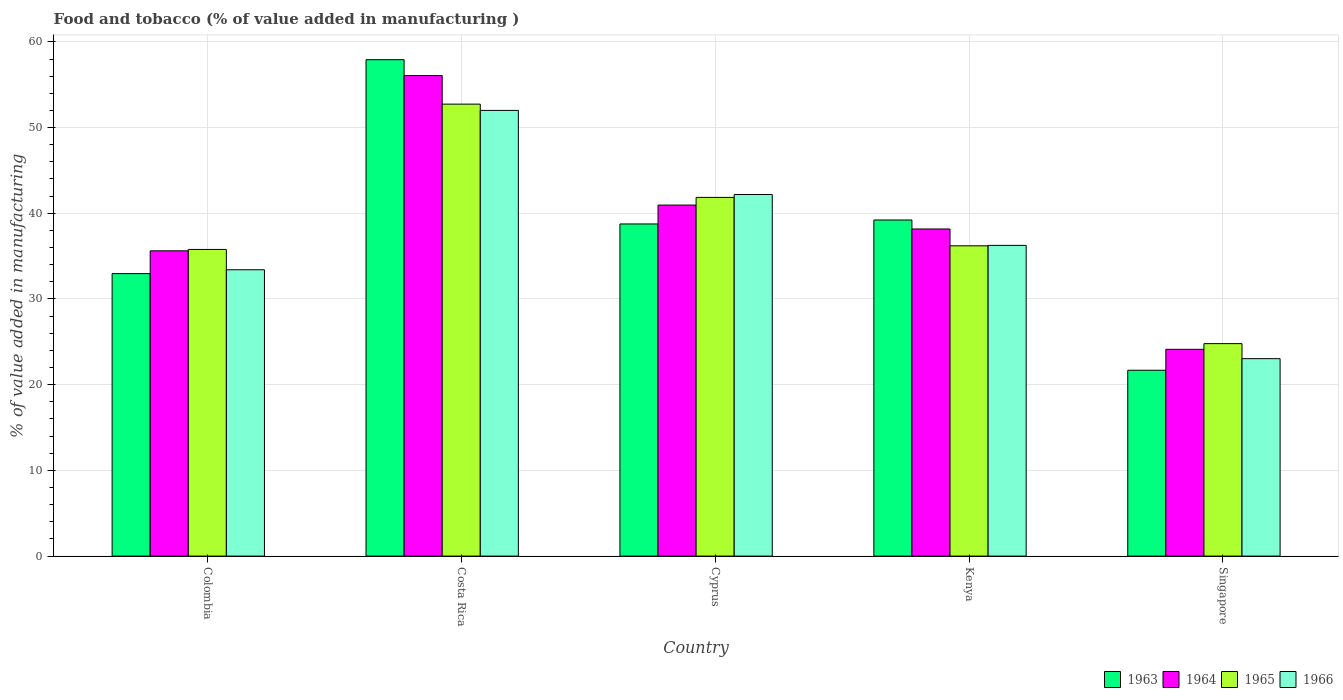How many different coloured bars are there?
Offer a terse response. 4. Are the number of bars per tick equal to the number of legend labels?
Your answer should be compact. Yes. Are the number of bars on each tick of the X-axis equal?
Keep it short and to the point. Yes. How many bars are there on the 2nd tick from the left?
Your answer should be very brief. 4. How many bars are there on the 2nd tick from the right?
Provide a succinct answer. 4. What is the label of the 1st group of bars from the left?
Make the answer very short. Colombia. In how many cases, is the number of bars for a given country not equal to the number of legend labels?
Ensure brevity in your answer.  0. What is the value added in manufacturing food and tobacco in 1963 in Cyprus?
Keep it short and to the point. 38.75. Across all countries, what is the maximum value added in manufacturing food and tobacco in 1963?
Your answer should be very brief. 57.92. Across all countries, what is the minimum value added in manufacturing food and tobacco in 1965?
Provide a succinct answer. 24.79. In which country was the value added in manufacturing food and tobacco in 1965 minimum?
Provide a short and direct response. Singapore. What is the total value added in manufacturing food and tobacco in 1963 in the graph?
Make the answer very short. 190.54. What is the difference between the value added in manufacturing food and tobacco in 1965 in Colombia and that in Singapore?
Keep it short and to the point. 10.99. What is the difference between the value added in manufacturing food and tobacco in 1964 in Colombia and the value added in manufacturing food and tobacco in 1963 in Singapore?
Offer a terse response. 13.93. What is the average value added in manufacturing food and tobacco in 1963 per country?
Provide a succinct answer. 38.11. What is the difference between the value added in manufacturing food and tobacco of/in 1963 and value added in manufacturing food and tobacco of/in 1965 in Cyprus?
Your response must be concise. -3.1. In how many countries, is the value added in manufacturing food and tobacco in 1963 greater than 54 %?
Ensure brevity in your answer.  1. What is the ratio of the value added in manufacturing food and tobacco in 1964 in Costa Rica to that in Kenya?
Your answer should be compact. 1.47. Is the difference between the value added in manufacturing food and tobacco in 1963 in Cyprus and Singapore greater than the difference between the value added in manufacturing food and tobacco in 1965 in Cyprus and Singapore?
Ensure brevity in your answer.  Yes. What is the difference between the highest and the second highest value added in manufacturing food and tobacco in 1964?
Offer a terse response. 15.11. What is the difference between the highest and the lowest value added in manufacturing food and tobacco in 1965?
Ensure brevity in your answer.  27.94. Is it the case that in every country, the sum of the value added in manufacturing food and tobacco in 1965 and value added in manufacturing food and tobacco in 1964 is greater than the sum of value added in manufacturing food and tobacco in 1966 and value added in manufacturing food and tobacco in 1963?
Give a very brief answer. No. What does the 4th bar from the left in Cyprus represents?
Your response must be concise. 1966. What does the 1st bar from the right in Singapore represents?
Offer a very short reply. 1966. Is it the case that in every country, the sum of the value added in manufacturing food and tobacco in 1963 and value added in manufacturing food and tobacco in 1966 is greater than the value added in manufacturing food and tobacco in 1964?
Offer a terse response. Yes. How many bars are there?
Offer a terse response. 20. How many countries are there in the graph?
Your answer should be very brief. 5. What is the difference between two consecutive major ticks on the Y-axis?
Offer a terse response. 10. Are the values on the major ticks of Y-axis written in scientific E-notation?
Give a very brief answer. No. How many legend labels are there?
Your answer should be very brief. 4. What is the title of the graph?
Offer a terse response. Food and tobacco (% of value added in manufacturing ). What is the label or title of the Y-axis?
Your response must be concise. % of value added in manufacturing. What is the % of value added in manufacturing of 1963 in Colombia?
Provide a succinct answer. 32.96. What is the % of value added in manufacturing of 1964 in Colombia?
Give a very brief answer. 35.62. What is the % of value added in manufacturing of 1965 in Colombia?
Ensure brevity in your answer.  35.78. What is the % of value added in manufacturing in 1966 in Colombia?
Give a very brief answer. 33.41. What is the % of value added in manufacturing of 1963 in Costa Rica?
Make the answer very short. 57.92. What is the % of value added in manufacturing in 1964 in Costa Rica?
Your response must be concise. 56.07. What is the % of value added in manufacturing of 1965 in Costa Rica?
Offer a terse response. 52.73. What is the % of value added in manufacturing in 1966 in Costa Rica?
Your answer should be very brief. 52. What is the % of value added in manufacturing in 1963 in Cyprus?
Your response must be concise. 38.75. What is the % of value added in manufacturing of 1964 in Cyprus?
Give a very brief answer. 40.96. What is the % of value added in manufacturing in 1965 in Cyprus?
Ensure brevity in your answer.  41.85. What is the % of value added in manufacturing of 1966 in Cyprus?
Your answer should be very brief. 42.19. What is the % of value added in manufacturing in 1963 in Kenya?
Keep it short and to the point. 39.22. What is the % of value added in manufacturing of 1964 in Kenya?
Provide a short and direct response. 38.17. What is the % of value added in manufacturing of 1965 in Kenya?
Ensure brevity in your answer.  36.2. What is the % of value added in manufacturing in 1966 in Kenya?
Ensure brevity in your answer.  36.25. What is the % of value added in manufacturing in 1963 in Singapore?
Provide a short and direct response. 21.69. What is the % of value added in manufacturing in 1964 in Singapore?
Make the answer very short. 24.13. What is the % of value added in manufacturing of 1965 in Singapore?
Your answer should be very brief. 24.79. What is the % of value added in manufacturing of 1966 in Singapore?
Keep it short and to the point. 23.04. Across all countries, what is the maximum % of value added in manufacturing in 1963?
Ensure brevity in your answer.  57.92. Across all countries, what is the maximum % of value added in manufacturing in 1964?
Keep it short and to the point. 56.07. Across all countries, what is the maximum % of value added in manufacturing of 1965?
Make the answer very short. 52.73. Across all countries, what is the maximum % of value added in manufacturing in 1966?
Offer a terse response. 52. Across all countries, what is the minimum % of value added in manufacturing of 1963?
Keep it short and to the point. 21.69. Across all countries, what is the minimum % of value added in manufacturing of 1964?
Make the answer very short. 24.13. Across all countries, what is the minimum % of value added in manufacturing of 1965?
Ensure brevity in your answer.  24.79. Across all countries, what is the minimum % of value added in manufacturing in 1966?
Offer a terse response. 23.04. What is the total % of value added in manufacturing in 1963 in the graph?
Provide a short and direct response. 190.54. What is the total % of value added in manufacturing of 1964 in the graph?
Give a very brief answer. 194.94. What is the total % of value added in manufacturing of 1965 in the graph?
Provide a short and direct response. 191.36. What is the total % of value added in manufacturing in 1966 in the graph?
Ensure brevity in your answer.  186.89. What is the difference between the % of value added in manufacturing in 1963 in Colombia and that in Costa Rica?
Your response must be concise. -24.96. What is the difference between the % of value added in manufacturing of 1964 in Colombia and that in Costa Rica?
Your response must be concise. -20.45. What is the difference between the % of value added in manufacturing of 1965 in Colombia and that in Costa Rica?
Offer a very short reply. -16.95. What is the difference between the % of value added in manufacturing in 1966 in Colombia and that in Costa Rica?
Offer a very short reply. -18.59. What is the difference between the % of value added in manufacturing in 1963 in Colombia and that in Cyprus?
Ensure brevity in your answer.  -5.79. What is the difference between the % of value added in manufacturing in 1964 in Colombia and that in Cyprus?
Provide a succinct answer. -5.34. What is the difference between the % of value added in manufacturing in 1965 in Colombia and that in Cyprus?
Provide a short and direct response. -6.07. What is the difference between the % of value added in manufacturing in 1966 in Colombia and that in Cyprus?
Your answer should be very brief. -8.78. What is the difference between the % of value added in manufacturing in 1963 in Colombia and that in Kenya?
Give a very brief answer. -6.26. What is the difference between the % of value added in manufacturing in 1964 in Colombia and that in Kenya?
Offer a terse response. -2.55. What is the difference between the % of value added in manufacturing of 1965 in Colombia and that in Kenya?
Keep it short and to the point. -0.42. What is the difference between the % of value added in manufacturing in 1966 in Colombia and that in Kenya?
Ensure brevity in your answer.  -2.84. What is the difference between the % of value added in manufacturing in 1963 in Colombia and that in Singapore?
Ensure brevity in your answer.  11.27. What is the difference between the % of value added in manufacturing of 1964 in Colombia and that in Singapore?
Give a very brief answer. 11.49. What is the difference between the % of value added in manufacturing in 1965 in Colombia and that in Singapore?
Keep it short and to the point. 10.99. What is the difference between the % of value added in manufacturing in 1966 in Colombia and that in Singapore?
Your answer should be very brief. 10.37. What is the difference between the % of value added in manufacturing in 1963 in Costa Rica and that in Cyprus?
Offer a terse response. 19.17. What is the difference between the % of value added in manufacturing of 1964 in Costa Rica and that in Cyprus?
Provide a short and direct response. 15.11. What is the difference between the % of value added in manufacturing of 1965 in Costa Rica and that in Cyprus?
Make the answer very short. 10.88. What is the difference between the % of value added in manufacturing in 1966 in Costa Rica and that in Cyprus?
Offer a very short reply. 9.82. What is the difference between the % of value added in manufacturing of 1963 in Costa Rica and that in Kenya?
Provide a succinct answer. 18.7. What is the difference between the % of value added in manufacturing in 1964 in Costa Rica and that in Kenya?
Give a very brief answer. 17.9. What is the difference between the % of value added in manufacturing in 1965 in Costa Rica and that in Kenya?
Make the answer very short. 16.53. What is the difference between the % of value added in manufacturing of 1966 in Costa Rica and that in Kenya?
Offer a terse response. 15.75. What is the difference between the % of value added in manufacturing in 1963 in Costa Rica and that in Singapore?
Keep it short and to the point. 36.23. What is the difference between the % of value added in manufacturing in 1964 in Costa Rica and that in Singapore?
Provide a short and direct response. 31.94. What is the difference between the % of value added in manufacturing of 1965 in Costa Rica and that in Singapore?
Your answer should be very brief. 27.94. What is the difference between the % of value added in manufacturing in 1966 in Costa Rica and that in Singapore?
Give a very brief answer. 28.97. What is the difference between the % of value added in manufacturing of 1963 in Cyprus and that in Kenya?
Your response must be concise. -0.46. What is the difference between the % of value added in manufacturing of 1964 in Cyprus and that in Kenya?
Provide a short and direct response. 2.79. What is the difference between the % of value added in manufacturing in 1965 in Cyprus and that in Kenya?
Your answer should be very brief. 5.65. What is the difference between the % of value added in manufacturing of 1966 in Cyprus and that in Kenya?
Offer a terse response. 5.93. What is the difference between the % of value added in manufacturing of 1963 in Cyprus and that in Singapore?
Your answer should be compact. 17.07. What is the difference between the % of value added in manufacturing in 1964 in Cyprus and that in Singapore?
Offer a very short reply. 16.83. What is the difference between the % of value added in manufacturing of 1965 in Cyprus and that in Singapore?
Your response must be concise. 17.06. What is the difference between the % of value added in manufacturing of 1966 in Cyprus and that in Singapore?
Your answer should be very brief. 19.15. What is the difference between the % of value added in manufacturing of 1963 in Kenya and that in Singapore?
Make the answer very short. 17.53. What is the difference between the % of value added in manufacturing in 1964 in Kenya and that in Singapore?
Your response must be concise. 14.04. What is the difference between the % of value added in manufacturing in 1965 in Kenya and that in Singapore?
Offer a very short reply. 11.41. What is the difference between the % of value added in manufacturing in 1966 in Kenya and that in Singapore?
Your answer should be compact. 13.22. What is the difference between the % of value added in manufacturing of 1963 in Colombia and the % of value added in manufacturing of 1964 in Costa Rica?
Your response must be concise. -23.11. What is the difference between the % of value added in manufacturing of 1963 in Colombia and the % of value added in manufacturing of 1965 in Costa Rica?
Ensure brevity in your answer.  -19.77. What is the difference between the % of value added in manufacturing of 1963 in Colombia and the % of value added in manufacturing of 1966 in Costa Rica?
Keep it short and to the point. -19.04. What is the difference between the % of value added in manufacturing of 1964 in Colombia and the % of value added in manufacturing of 1965 in Costa Rica?
Give a very brief answer. -17.11. What is the difference between the % of value added in manufacturing of 1964 in Colombia and the % of value added in manufacturing of 1966 in Costa Rica?
Offer a terse response. -16.38. What is the difference between the % of value added in manufacturing in 1965 in Colombia and the % of value added in manufacturing in 1966 in Costa Rica?
Your answer should be very brief. -16.22. What is the difference between the % of value added in manufacturing in 1963 in Colombia and the % of value added in manufacturing in 1964 in Cyprus?
Provide a short and direct response. -8. What is the difference between the % of value added in manufacturing of 1963 in Colombia and the % of value added in manufacturing of 1965 in Cyprus?
Keep it short and to the point. -8.89. What is the difference between the % of value added in manufacturing in 1963 in Colombia and the % of value added in manufacturing in 1966 in Cyprus?
Provide a short and direct response. -9.23. What is the difference between the % of value added in manufacturing in 1964 in Colombia and the % of value added in manufacturing in 1965 in Cyprus?
Ensure brevity in your answer.  -6.23. What is the difference between the % of value added in manufacturing in 1964 in Colombia and the % of value added in manufacturing in 1966 in Cyprus?
Give a very brief answer. -6.57. What is the difference between the % of value added in manufacturing in 1965 in Colombia and the % of value added in manufacturing in 1966 in Cyprus?
Give a very brief answer. -6.41. What is the difference between the % of value added in manufacturing in 1963 in Colombia and the % of value added in manufacturing in 1964 in Kenya?
Your answer should be compact. -5.21. What is the difference between the % of value added in manufacturing in 1963 in Colombia and the % of value added in manufacturing in 1965 in Kenya?
Ensure brevity in your answer.  -3.24. What is the difference between the % of value added in manufacturing of 1963 in Colombia and the % of value added in manufacturing of 1966 in Kenya?
Keep it short and to the point. -3.29. What is the difference between the % of value added in manufacturing in 1964 in Colombia and the % of value added in manufacturing in 1965 in Kenya?
Provide a short and direct response. -0.58. What is the difference between the % of value added in manufacturing in 1964 in Colombia and the % of value added in manufacturing in 1966 in Kenya?
Offer a very short reply. -0.63. What is the difference between the % of value added in manufacturing of 1965 in Colombia and the % of value added in manufacturing of 1966 in Kenya?
Keep it short and to the point. -0.47. What is the difference between the % of value added in manufacturing in 1963 in Colombia and the % of value added in manufacturing in 1964 in Singapore?
Offer a very short reply. 8.83. What is the difference between the % of value added in manufacturing of 1963 in Colombia and the % of value added in manufacturing of 1965 in Singapore?
Offer a terse response. 8.17. What is the difference between the % of value added in manufacturing in 1963 in Colombia and the % of value added in manufacturing in 1966 in Singapore?
Your response must be concise. 9.92. What is the difference between the % of value added in manufacturing in 1964 in Colombia and the % of value added in manufacturing in 1965 in Singapore?
Your answer should be very brief. 10.83. What is the difference between the % of value added in manufacturing of 1964 in Colombia and the % of value added in manufacturing of 1966 in Singapore?
Your response must be concise. 12.58. What is the difference between the % of value added in manufacturing in 1965 in Colombia and the % of value added in manufacturing in 1966 in Singapore?
Your answer should be very brief. 12.74. What is the difference between the % of value added in manufacturing of 1963 in Costa Rica and the % of value added in manufacturing of 1964 in Cyprus?
Your answer should be compact. 16.96. What is the difference between the % of value added in manufacturing of 1963 in Costa Rica and the % of value added in manufacturing of 1965 in Cyprus?
Offer a very short reply. 16.07. What is the difference between the % of value added in manufacturing of 1963 in Costa Rica and the % of value added in manufacturing of 1966 in Cyprus?
Ensure brevity in your answer.  15.73. What is the difference between the % of value added in manufacturing in 1964 in Costa Rica and the % of value added in manufacturing in 1965 in Cyprus?
Keep it short and to the point. 14.21. What is the difference between the % of value added in manufacturing of 1964 in Costa Rica and the % of value added in manufacturing of 1966 in Cyprus?
Your answer should be very brief. 13.88. What is the difference between the % of value added in manufacturing in 1965 in Costa Rica and the % of value added in manufacturing in 1966 in Cyprus?
Give a very brief answer. 10.55. What is the difference between the % of value added in manufacturing of 1963 in Costa Rica and the % of value added in manufacturing of 1964 in Kenya?
Your answer should be compact. 19.75. What is the difference between the % of value added in manufacturing in 1963 in Costa Rica and the % of value added in manufacturing in 1965 in Kenya?
Make the answer very short. 21.72. What is the difference between the % of value added in manufacturing of 1963 in Costa Rica and the % of value added in manufacturing of 1966 in Kenya?
Your answer should be very brief. 21.67. What is the difference between the % of value added in manufacturing in 1964 in Costa Rica and the % of value added in manufacturing in 1965 in Kenya?
Your answer should be compact. 19.86. What is the difference between the % of value added in manufacturing of 1964 in Costa Rica and the % of value added in manufacturing of 1966 in Kenya?
Offer a very short reply. 19.81. What is the difference between the % of value added in manufacturing of 1965 in Costa Rica and the % of value added in manufacturing of 1966 in Kenya?
Your answer should be very brief. 16.48. What is the difference between the % of value added in manufacturing of 1963 in Costa Rica and the % of value added in manufacturing of 1964 in Singapore?
Give a very brief answer. 33.79. What is the difference between the % of value added in manufacturing in 1963 in Costa Rica and the % of value added in manufacturing in 1965 in Singapore?
Provide a succinct answer. 33.13. What is the difference between the % of value added in manufacturing in 1963 in Costa Rica and the % of value added in manufacturing in 1966 in Singapore?
Make the answer very short. 34.88. What is the difference between the % of value added in manufacturing of 1964 in Costa Rica and the % of value added in manufacturing of 1965 in Singapore?
Offer a terse response. 31.28. What is the difference between the % of value added in manufacturing of 1964 in Costa Rica and the % of value added in manufacturing of 1966 in Singapore?
Your answer should be compact. 33.03. What is the difference between the % of value added in manufacturing in 1965 in Costa Rica and the % of value added in manufacturing in 1966 in Singapore?
Make the answer very short. 29.7. What is the difference between the % of value added in manufacturing in 1963 in Cyprus and the % of value added in manufacturing in 1964 in Kenya?
Make the answer very short. 0.59. What is the difference between the % of value added in manufacturing in 1963 in Cyprus and the % of value added in manufacturing in 1965 in Kenya?
Your response must be concise. 2.55. What is the difference between the % of value added in manufacturing in 1963 in Cyprus and the % of value added in manufacturing in 1966 in Kenya?
Your answer should be very brief. 2.5. What is the difference between the % of value added in manufacturing of 1964 in Cyprus and the % of value added in manufacturing of 1965 in Kenya?
Give a very brief answer. 4.75. What is the difference between the % of value added in manufacturing of 1964 in Cyprus and the % of value added in manufacturing of 1966 in Kenya?
Offer a very short reply. 4.7. What is the difference between the % of value added in manufacturing in 1965 in Cyprus and the % of value added in manufacturing in 1966 in Kenya?
Provide a succinct answer. 5.6. What is the difference between the % of value added in manufacturing in 1963 in Cyprus and the % of value added in manufacturing in 1964 in Singapore?
Your response must be concise. 14.63. What is the difference between the % of value added in manufacturing of 1963 in Cyprus and the % of value added in manufacturing of 1965 in Singapore?
Offer a terse response. 13.96. What is the difference between the % of value added in manufacturing of 1963 in Cyprus and the % of value added in manufacturing of 1966 in Singapore?
Give a very brief answer. 15.72. What is the difference between the % of value added in manufacturing in 1964 in Cyprus and the % of value added in manufacturing in 1965 in Singapore?
Your answer should be compact. 16.17. What is the difference between the % of value added in manufacturing of 1964 in Cyprus and the % of value added in manufacturing of 1966 in Singapore?
Offer a terse response. 17.92. What is the difference between the % of value added in manufacturing in 1965 in Cyprus and the % of value added in manufacturing in 1966 in Singapore?
Your answer should be very brief. 18.82. What is the difference between the % of value added in manufacturing in 1963 in Kenya and the % of value added in manufacturing in 1964 in Singapore?
Keep it short and to the point. 15.09. What is the difference between the % of value added in manufacturing in 1963 in Kenya and the % of value added in manufacturing in 1965 in Singapore?
Keep it short and to the point. 14.43. What is the difference between the % of value added in manufacturing of 1963 in Kenya and the % of value added in manufacturing of 1966 in Singapore?
Offer a very short reply. 16.18. What is the difference between the % of value added in manufacturing in 1964 in Kenya and the % of value added in manufacturing in 1965 in Singapore?
Your response must be concise. 13.38. What is the difference between the % of value added in manufacturing in 1964 in Kenya and the % of value added in manufacturing in 1966 in Singapore?
Keep it short and to the point. 15.13. What is the difference between the % of value added in manufacturing of 1965 in Kenya and the % of value added in manufacturing of 1966 in Singapore?
Give a very brief answer. 13.17. What is the average % of value added in manufacturing of 1963 per country?
Provide a succinct answer. 38.11. What is the average % of value added in manufacturing of 1964 per country?
Ensure brevity in your answer.  38.99. What is the average % of value added in manufacturing of 1965 per country?
Offer a terse response. 38.27. What is the average % of value added in manufacturing in 1966 per country?
Make the answer very short. 37.38. What is the difference between the % of value added in manufacturing in 1963 and % of value added in manufacturing in 1964 in Colombia?
Provide a short and direct response. -2.66. What is the difference between the % of value added in manufacturing of 1963 and % of value added in manufacturing of 1965 in Colombia?
Offer a very short reply. -2.82. What is the difference between the % of value added in manufacturing in 1963 and % of value added in manufacturing in 1966 in Colombia?
Your response must be concise. -0.45. What is the difference between the % of value added in manufacturing of 1964 and % of value added in manufacturing of 1965 in Colombia?
Provide a short and direct response. -0.16. What is the difference between the % of value added in manufacturing in 1964 and % of value added in manufacturing in 1966 in Colombia?
Ensure brevity in your answer.  2.21. What is the difference between the % of value added in manufacturing of 1965 and % of value added in manufacturing of 1966 in Colombia?
Keep it short and to the point. 2.37. What is the difference between the % of value added in manufacturing of 1963 and % of value added in manufacturing of 1964 in Costa Rica?
Offer a very short reply. 1.85. What is the difference between the % of value added in manufacturing in 1963 and % of value added in manufacturing in 1965 in Costa Rica?
Keep it short and to the point. 5.19. What is the difference between the % of value added in manufacturing in 1963 and % of value added in manufacturing in 1966 in Costa Rica?
Your response must be concise. 5.92. What is the difference between the % of value added in manufacturing in 1964 and % of value added in manufacturing in 1965 in Costa Rica?
Provide a succinct answer. 3.33. What is the difference between the % of value added in manufacturing in 1964 and % of value added in manufacturing in 1966 in Costa Rica?
Provide a succinct answer. 4.06. What is the difference between the % of value added in manufacturing in 1965 and % of value added in manufacturing in 1966 in Costa Rica?
Your response must be concise. 0.73. What is the difference between the % of value added in manufacturing of 1963 and % of value added in manufacturing of 1964 in Cyprus?
Provide a succinct answer. -2.2. What is the difference between the % of value added in manufacturing in 1963 and % of value added in manufacturing in 1965 in Cyprus?
Your response must be concise. -3.1. What is the difference between the % of value added in manufacturing of 1963 and % of value added in manufacturing of 1966 in Cyprus?
Your response must be concise. -3.43. What is the difference between the % of value added in manufacturing of 1964 and % of value added in manufacturing of 1965 in Cyprus?
Provide a short and direct response. -0.9. What is the difference between the % of value added in manufacturing in 1964 and % of value added in manufacturing in 1966 in Cyprus?
Offer a terse response. -1.23. What is the difference between the % of value added in manufacturing of 1963 and % of value added in manufacturing of 1964 in Kenya?
Provide a succinct answer. 1.05. What is the difference between the % of value added in manufacturing in 1963 and % of value added in manufacturing in 1965 in Kenya?
Ensure brevity in your answer.  3.01. What is the difference between the % of value added in manufacturing of 1963 and % of value added in manufacturing of 1966 in Kenya?
Make the answer very short. 2.96. What is the difference between the % of value added in manufacturing of 1964 and % of value added in manufacturing of 1965 in Kenya?
Offer a terse response. 1.96. What is the difference between the % of value added in manufacturing of 1964 and % of value added in manufacturing of 1966 in Kenya?
Your answer should be very brief. 1.91. What is the difference between the % of value added in manufacturing of 1963 and % of value added in manufacturing of 1964 in Singapore?
Offer a very short reply. -2.44. What is the difference between the % of value added in manufacturing of 1963 and % of value added in manufacturing of 1965 in Singapore?
Give a very brief answer. -3.1. What is the difference between the % of value added in manufacturing of 1963 and % of value added in manufacturing of 1966 in Singapore?
Your response must be concise. -1.35. What is the difference between the % of value added in manufacturing of 1964 and % of value added in manufacturing of 1965 in Singapore?
Your answer should be compact. -0.66. What is the difference between the % of value added in manufacturing in 1964 and % of value added in manufacturing in 1966 in Singapore?
Provide a short and direct response. 1.09. What is the difference between the % of value added in manufacturing of 1965 and % of value added in manufacturing of 1966 in Singapore?
Provide a succinct answer. 1.75. What is the ratio of the % of value added in manufacturing of 1963 in Colombia to that in Costa Rica?
Make the answer very short. 0.57. What is the ratio of the % of value added in manufacturing of 1964 in Colombia to that in Costa Rica?
Offer a very short reply. 0.64. What is the ratio of the % of value added in manufacturing in 1965 in Colombia to that in Costa Rica?
Your answer should be very brief. 0.68. What is the ratio of the % of value added in manufacturing of 1966 in Colombia to that in Costa Rica?
Your response must be concise. 0.64. What is the ratio of the % of value added in manufacturing of 1963 in Colombia to that in Cyprus?
Your response must be concise. 0.85. What is the ratio of the % of value added in manufacturing in 1964 in Colombia to that in Cyprus?
Keep it short and to the point. 0.87. What is the ratio of the % of value added in manufacturing of 1965 in Colombia to that in Cyprus?
Offer a terse response. 0.85. What is the ratio of the % of value added in manufacturing of 1966 in Colombia to that in Cyprus?
Provide a succinct answer. 0.79. What is the ratio of the % of value added in manufacturing of 1963 in Colombia to that in Kenya?
Offer a terse response. 0.84. What is the ratio of the % of value added in manufacturing in 1964 in Colombia to that in Kenya?
Offer a terse response. 0.93. What is the ratio of the % of value added in manufacturing in 1965 in Colombia to that in Kenya?
Offer a terse response. 0.99. What is the ratio of the % of value added in manufacturing in 1966 in Colombia to that in Kenya?
Keep it short and to the point. 0.92. What is the ratio of the % of value added in manufacturing in 1963 in Colombia to that in Singapore?
Make the answer very short. 1.52. What is the ratio of the % of value added in manufacturing in 1964 in Colombia to that in Singapore?
Your response must be concise. 1.48. What is the ratio of the % of value added in manufacturing of 1965 in Colombia to that in Singapore?
Provide a short and direct response. 1.44. What is the ratio of the % of value added in manufacturing in 1966 in Colombia to that in Singapore?
Your response must be concise. 1.45. What is the ratio of the % of value added in manufacturing in 1963 in Costa Rica to that in Cyprus?
Provide a succinct answer. 1.49. What is the ratio of the % of value added in manufacturing of 1964 in Costa Rica to that in Cyprus?
Your response must be concise. 1.37. What is the ratio of the % of value added in manufacturing in 1965 in Costa Rica to that in Cyprus?
Offer a terse response. 1.26. What is the ratio of the % of value added in manufacturing of 1966 in Costa Rica to that in Cyprus?
Give a very brief answer. 1.23. What is the ratio of the % of value added in manufacturing in 1963 in Costa Rica to that in Kenya?
Offer a terse response. 1.48. What is the ratio of the % of value added in manufacturing of 1964 in Costa Rica to that in Kenya?
Provide a short and direct response. 1.47. What is the ratio of the % of value added in manufacturing in 1965 in Costa Rica to that in Kenya?
Provide a succinct answer. 1.46. What is the ratio of the % of value added in manufacturing in 1966 in Costa Rica to that in Kenya?
Provide a short and direct response. 1.43. What is the ratio of the % of value added in manufacturing of 1963 in Costa Rica to that in Singapore?
Give a very brief answer. 2.67. What is the ratio of the % of value added in manufacturing of 1964 in Costa Rica to that in Singapore?
Offer a terse response. 2.32. What is the ratio of the % of value added in manufacturing of 1965 in Costa Rica to that in Singapore?
Offer a terse response. 2.13. What is the ratio of the % of value added in manufacturing in 1966 in Costa Rica to that in Singapore?
Offer a very short reply. 2.26. What is the ratio of the % of value added in manufacturing of 1964 in Cyprus to that in Kenya?
Your response must be concise. 1.07. What is the ratio of the % of value added in manufacturing in 1965 in Cyprus to that in Kenya?
Your response must be concise. 1.16. What is the ratio of the % of value added in manufacturing in 1966 in Cyprus to that in Kenya?
Your answer should be very brief. 1.16. What is the ratio of the % of value added in manufacturing of 1963 in Cyprus to that in Singapore?
Your answer should be very brief. 1.79. What is the ratio of the % of value added in manufacturing in 1964 in Cyprus to that in Singapore?
Give a very brief answer. 1.7. What is the ratio of the % of value added in manufacturing in 1965 in Cyprus to that in Singapore?
Offer a terse response. 1.69. What is the ratio of the % of value added in manufacturing of 1966 in Cyprus to that in Singapore?
Your answer should be very brief. 1.83. What is the ratio of the % of value added in manufacturing in 1963 in Kenya to that in Singapore?
Your answer should be compact. 1.81. What is the ratio of the % of value added in manufacturing in 1964 in Kenya to that in Singapore?
Keep it short and to the point. 1.58. What is the ratio of the % of value added in manufacturing in 1965 in Kenya to that in Singapore?
Your answer should be compact. 1.46. What is the ratio of the % of value added in manufacturing in 1966 in Kenya to that in Singapore?
Your answer should be compact. 1.57. What is the difference between the highest and the second highest % of value added in manufacturing of 1963?
Your answer should be very brief. 18.7. What is the difference between the highest and the second highest % of value added in manufacturing in 1964?
Provide a succinct answer. 15.11. What is the difference between the highest and the second highest % of value added in manufacturing of 1965?
Your answer should be very brief. 10.88. What is the difference between the highest and the second highest % of value added in manufacturing in 1966?
Provide a succinct answer. 9.82. What is the difference between the highest and the lowest % of value added in manufacturing in 1963?
Your answer should be very brief. 36.23. What is the difference between the highest and the lowest % of value added in manufacturing in 1964?
Offer a terse response. 31.94. What is the difference between the highest and the lowest % of value added in manufacturing in 1965?
Ensure brevity in your answer.  27.94. What is the difference between the highest and the lowest % of value added in manufacturing in 1966?
Your response must be concise. 28.97. 